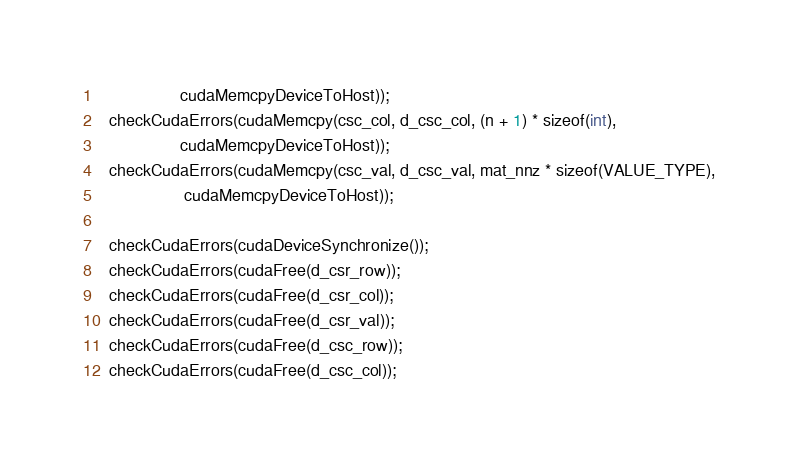<code> <loc_0><loc_0><loc_500><loc_500><_Cuda_>                 cudaMemcpyDeviceToHost));
  checkCudaErrors(cudaMemcpy(csc_col, d_csc_col, (n + 1) * sizeof(int),   
                 cudaMemcpyDeviceToHost));
  checkCudaErrors(cudaMemcpy(csc_val, d_csc_val, mat_nnz * sizeof(VALUE_TYPE),
                  cudaMemcpyDeviceToHost));

  checkCudaErrors(cudaDeviceSynchronize());
  checkCudaErrors(cudaFree(d_csr_row));
  checkCudaErrors(cudaFree(d_csr_col));
  checkCudaErrors(cudaFree(d_csr_val));
  checkCudaErrors(cudaFree(d_csc_row));
  checkCudaErrors(cudaFree(d_csc_col));</code> 